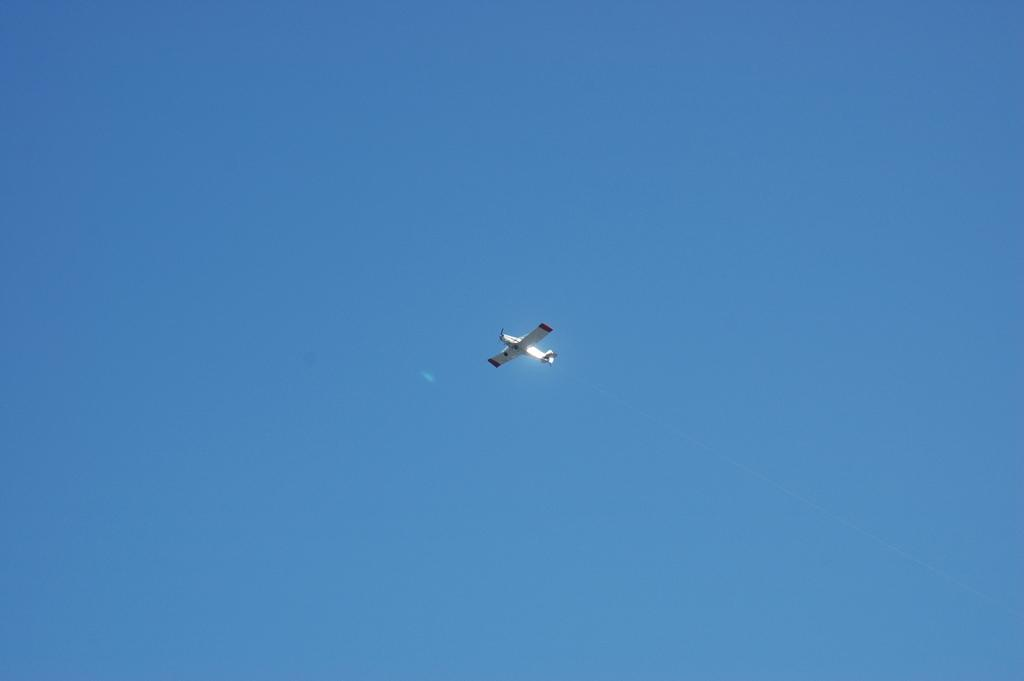What is the main subject of the image? The main subject of the image is an airplane. What is the airplane doing in the image? The airplane is flying in the sky. What type of beetle can be seen playing a whistle in the image? There is no beetle or whistle present in the image; it features an airplane flying in the sky. 